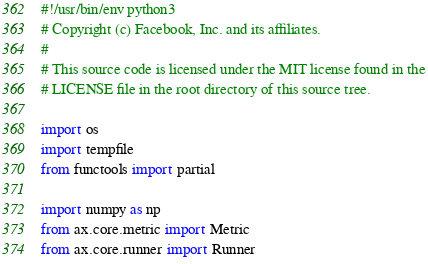Convert code to text. <code><loc_0><loc_0><loc_500><loc_500><_Python_>#!/usr/bin/env python3
# Copyright (c) Facebook, Inc. and its affiliates.
#
# This source code is licensed under the MIT license found in the
# LICENSE file in the root directory of this source tree.

import os
import tempfile
from functools import partial

import numpy as np
from ax.core.metric import Metric
from ax.core.runner import Runner</code> 